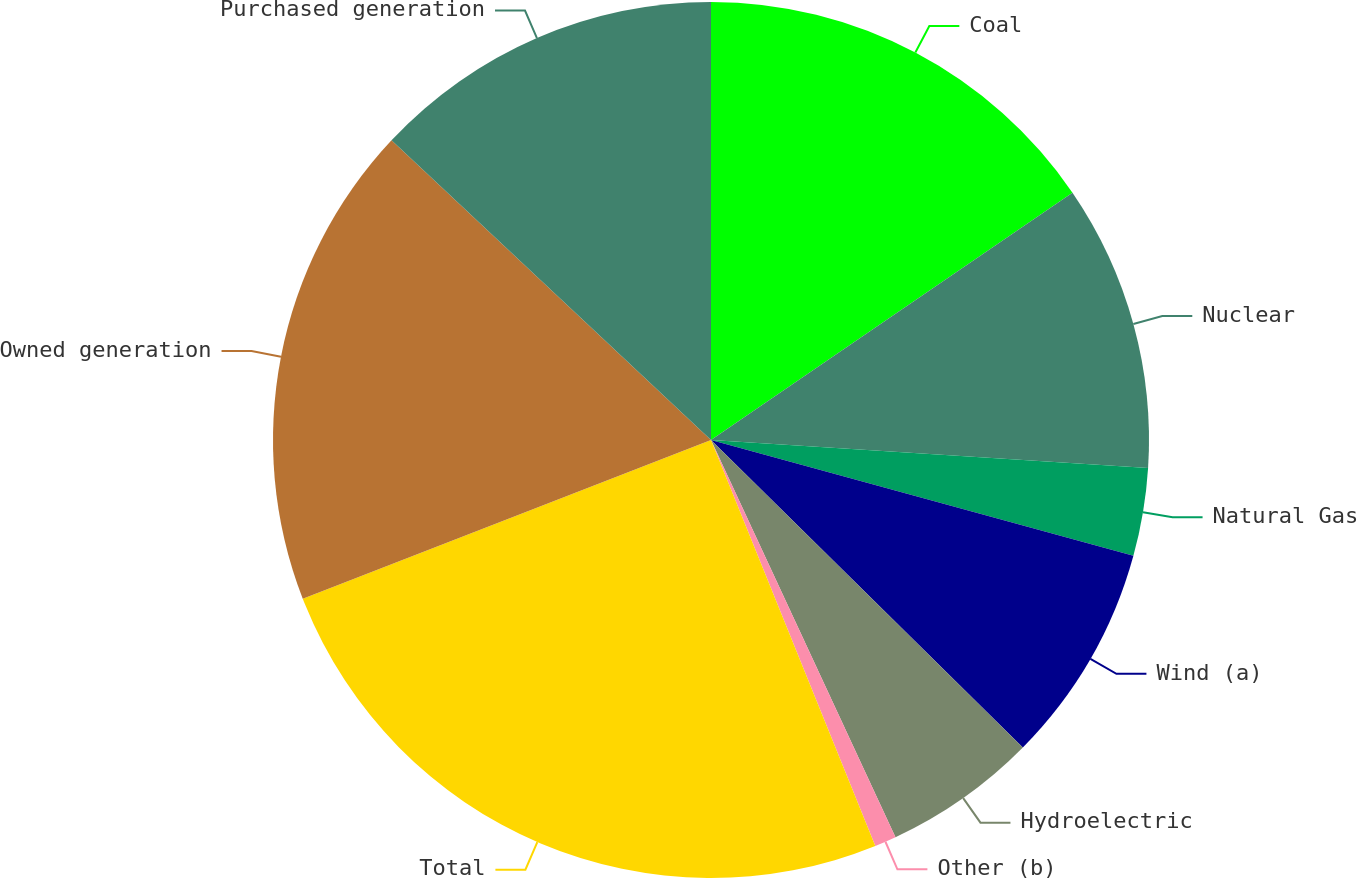<chart> <loc_0><loc_0><loc_500><loc_500><pie_chart><fcel>Coal<fcel>Nuclear<fcel>Natural Gas<fcel>Wind (a)<fcel>Hydroelectric<fcel>Other (b)<fcel>Total<fcel>Owned generation<fcel>Purchased generation<nl><fcel>15.45%<fcel>10.57%<fcel>3.24%<fcel>8.13%<fcel>5.69%<fcel>0.8%<fcel>25.22%<fcel>17.89%<fcel>13.01%<nl></chart> 